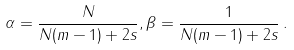<formula> <loc_0><loc_0><loc_500><loc_500>\alpha = \frac { N } { N ( m - 1 ) + 2 s } , \beta = \frac { 1 } { N ( m - 1 ) + 2 s } \, .</formula> 